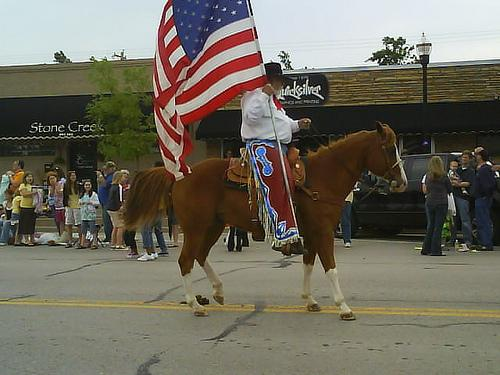What are the white marks on the horse's legs called? Please explain your reasoning. socks. The horse has white feet. 